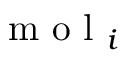<formula> <loc_0><loc_0><loc_500><loc_500>m o l _ { i }</formula> 